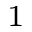Convert formula to latex. <formula><loc_0><loc_0><loc_500><loc_500>^ { 1 }</formula> 